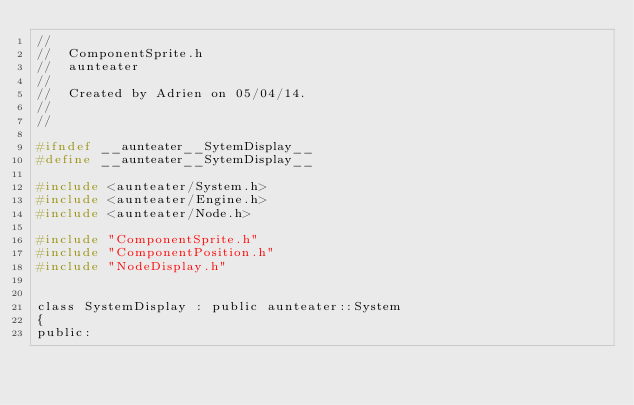Convert code to text. <code><loc_0><loc_0><loc_500><loc_500><_C_>//
//  ComponentSprite.h
//  aunteater
//
//  Created by Adrien on 05/04/14.
//
//

#ifndef __aunteater__SytemDisplay__
#define __aunteater__SytemDisplay__

#include <aunteater/System.h>
#include <aunteater/Engine.h>
#include <aunteater/Node.h>

#include "ComponentSprite.h"
#include "ComponentPosition.h"
#include "NodeDisplay.h"


class SystemDisplay : public aunteater::System
{
public:</code> 